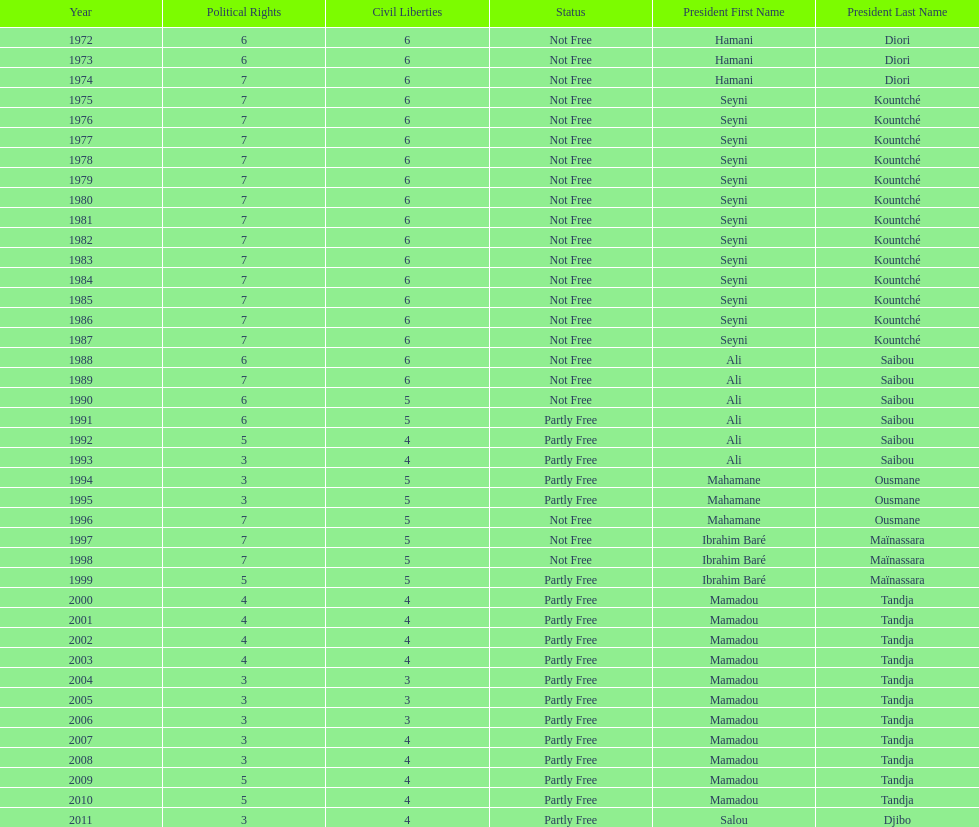Who was president before mamadou tandja? Ibrahim Baré Maïnassara. Would you mind parsing the complete table? {'header': ['Year', 'Political Rights', 'Civil Liberties', 'Status', 'President First Name', 'President Last Name'], 'rows': [['1972', '6', '6', 'Not Free', 'Hamani', 'Diori'], ['1973', '6', '6', 'Not Free', 'Hamani', 'Diori'], ['1974', '7', '6', 'Not Free', 'Hamani', 'Diori'], ['1975', '7', '6', 'Not Free', 'Seyni', 'Kountché'], ['1976', '7', '6', 'Not Free', 'Seyni', 'Kountché'], ['1977', '7', '6', 'Not Free', 'Seyni', 'Kountché'], ['1978', '7', '6', 'Not Free', 'Seyni', 'Kountché'], ['1979', '7', '6', 'Not Free', 'Seyni', 'Kountché'], ['1980', '7', '6', 'Not Free', 'Seyni', 'Kountché'], ['1981', '7', '6', 'Not Free', 'Seyni', 'Kountché'], ['1982', '7', '6', 'Not Free', 'Seyni', 'Kountché'], ['1983', '7', '6', 'Not Free', 'Seyni', 'Kountché'], ['1984', '7', '6', 'Not Free', 'Seyni', 'Kountché'], ['1985', '7', '6', 'Not Free', 'Seyni', 'Kountché'], ['1986', '7', '6', 'Not Free', 'Seyni', 'Kountché'], ['1987', '7', '6', 'Not Free', 'Seyni', 'Kountché'], ['1988', '6', '6', 'Not Free', 'Ali', 'Saibou'], ['1989', '7', '6', 'Not Free', 'Ali', 'Saibou'], ['1990', '6', '5', 'Not Free', 'Ali', 'Saibou'], ['1991', '6', '5', 'Partly Free', 'Ali', 'Saibou'], ['1992', '5', '4', 'Partly Free', 'Ali', 'Saibou'], ['1993', '3', '4', 'Partly Free', 'Ali', 'Saibou'], ['1994', '3', '5', 'Partly Free', 'Mahamane', 'Ousmane'], ['1995', '3', '5', 'Partly Free', 'Mahamane', 'Ousmane'], ['1996', '7', '5', 'Not Free', 'Mahamane', 'Ousmane'], ['1997', '7', '5', 'Not Free', 'Ibrahim Baré', 'Maïnassara'], ['1998', '7', '5', 'Not Free', 'Ibrahim Baré', 'Maïnassara'], ['1999', '5', '5', 'Partly Free', 'Ibrahim Baré', 'Maïnassara'], ['2000', '4', '4', 'Partly Free', 'Mamadou', 'Tandja'], ['2001', '4', '4', 'Partly Free', 'Mamadou', 'Tandja'], ['2002', '4', '4', 'Partly Free', 'Mamadou', 'Tandja'], ['2003', '4', '4', 'Partly Free', 'Mamadou', 'Tandja'], ['2004', '3', '3', 'Partly Free', 'Mamadou', 'Tandja'], ['2005', '3', '3', 'Partly Free', 'Mamadou', 'Tandja'], ['2006', '3', '3', 'Partly Free', 'Mamadou', 'Tandja'], ['2007', '3', '4', 'Partly Free', 'Mamadou', 'Tandja'], ['2008', '3', '4', 'Partly Free', 'Mamadou', 'Tandja'], ['2009', '5', '4', 'Partly Free', 'Mamadou', 'Tandja'], ['2010', '5', '4', 'Partly Free', 'Mamadou', 'Tandja'], ['2011', '3', '4', 'Partly Free', 'Salou', 'Djibo']]} 